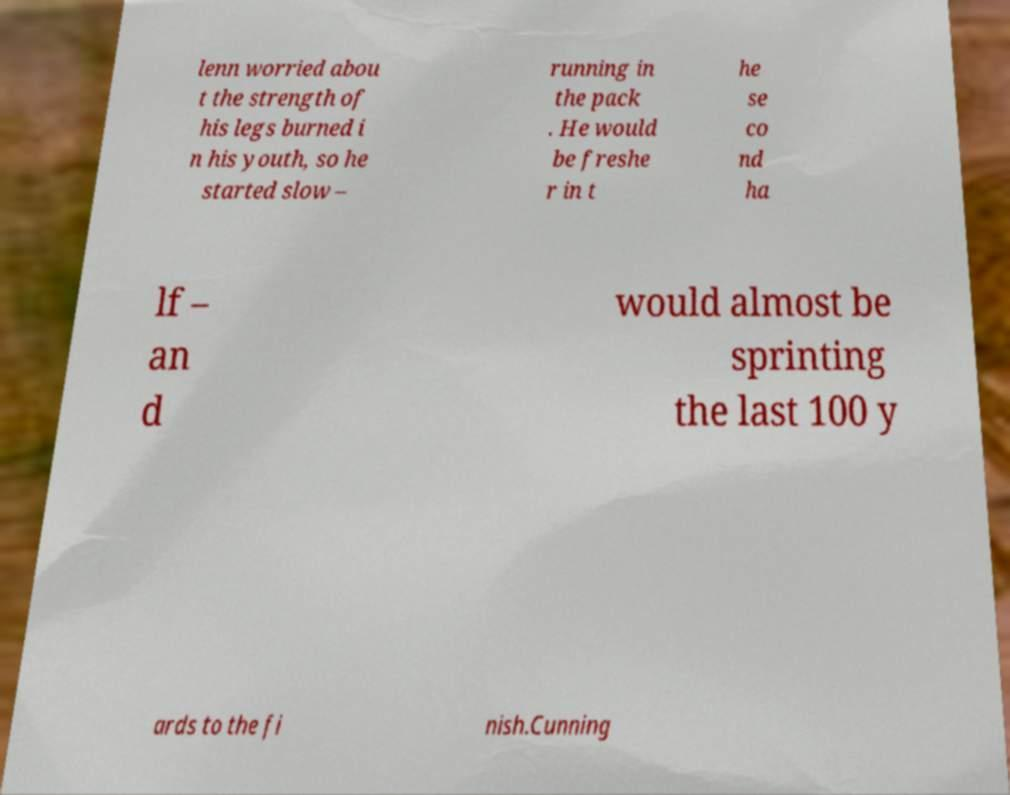Please identify and transcribe the text found in this image. lenn worried abou t the strength of his legs burned i n his youth, so he started slow – running in the pack . He would be freshe r in t he se co nd ha lf – an d would almost be sprinting the last 100 y ards to the fi nish.Cunning 